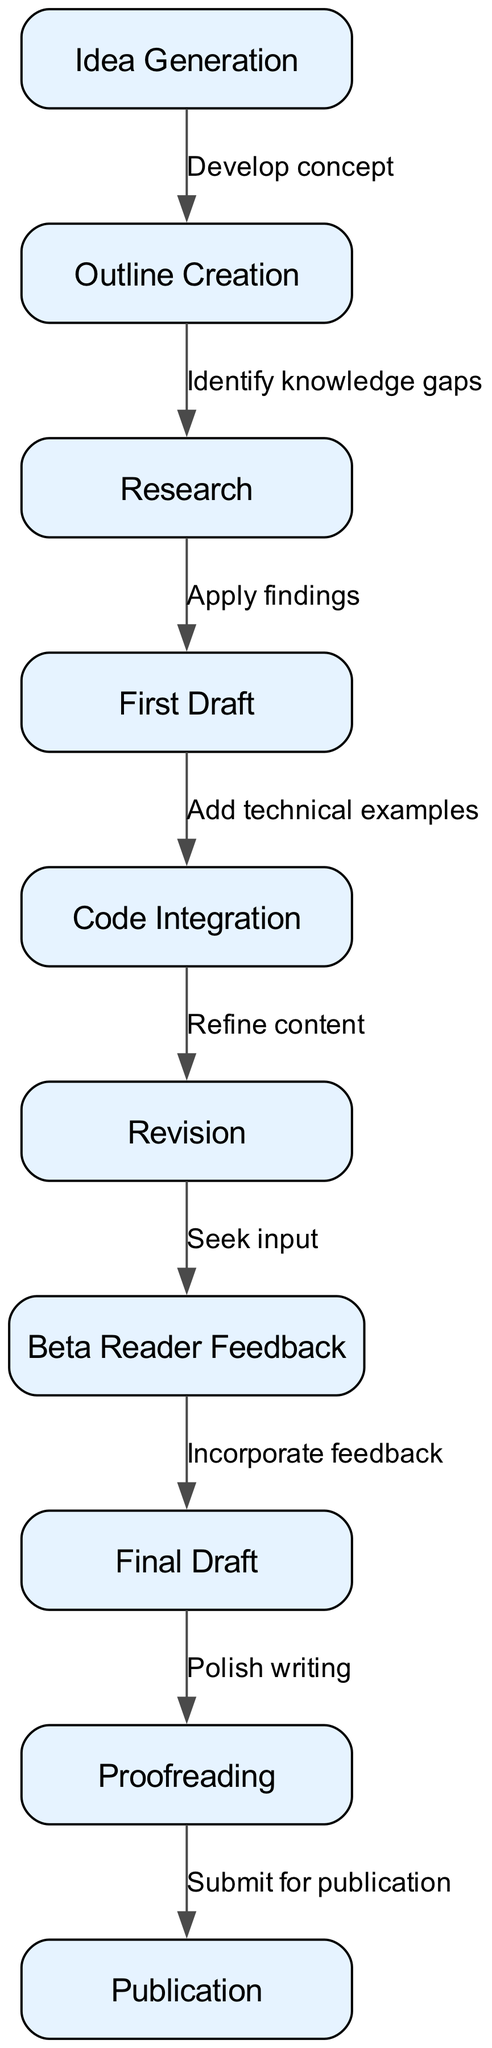What is the first step in the writing process flowchart? The first node in the diagram is labeled "Idea Generation". Therefore, it is the initial step in the writing process.
Answer: Idea Generation How many nodes are present in the flowchart? By counting the nodes provided in the "nodes" section, there are a total of 10 nodes in the diagram.
Answer: 10 Which step comes after "First Draft"? Referring to the flowchart, the step that directly follows "First Draft" is "Code Integration". This is indicated by the directed edge leading from the first to the latter.
Answer: Code Integration What content should be incorporated based on "Beta Reader Feedback"? The "Beta Reader Feedback" node leads to the "Final Draft" node, which specifies the action of incorporating feedback into the draft.
Answer: Incorporate feedback How many edges connect the nodes in the diagram? To determine the number of edges, we can count the connections as listed in the "edges" section. There are 9 edges present, connecting the nodes in a directed manner.
Answer: 9 What is the relationship between "Outline Creation" and "Research"? The edge connecting "Outline Creation" to "Research" indicates that the action is to identify knowledge gaps that arise after outlining is complete. This establishes a sequential relationship between the two steps.
Answer: Identify knowledge gaps What is the final step before publication? In the flow of the diagram, the last action before reaching "Publication" is "Proofreading". This node directly precedes the publication action.
Answer: Proofreading Which process follows "Revision"? Looking at the flowchart, "Revision" is followed by the process of seeking input through "Beta Reader Feedback", as indicated by the directed edge leading from "Revision".
Answer: Beta Reader Feedback What action should be taken after "Research"? "Research" is followed by the action of "First Draft", as shown by the directed flow from "Research" to "First Draft".
Answer: First Draft 